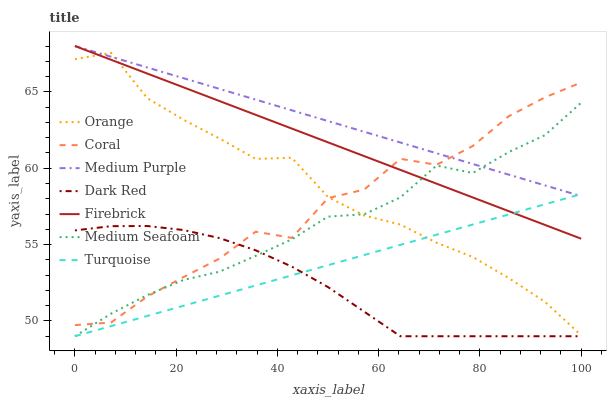Does Coral have the minimum area under the curve?
Answer yes or no. No. Does Coral have the maximum area under the curve?
Answer yes or no. No. Is Dark Red the smoothest?
Answer yes or no. No. Is Dark Red the roughest?
Answer yes or no. No. Does Coral have the lowest value?
Answer yes or no. No. Does Coral have the highest value?
Answer yes or no. No. Is Dark Red less than Firebrick?
Answer yes or no. Yes. Is Firebrick greater than Dark Red?
Answer yes or no. Yes. Does Dark Red intersect Firebrick?
Answer yes or no. No. 